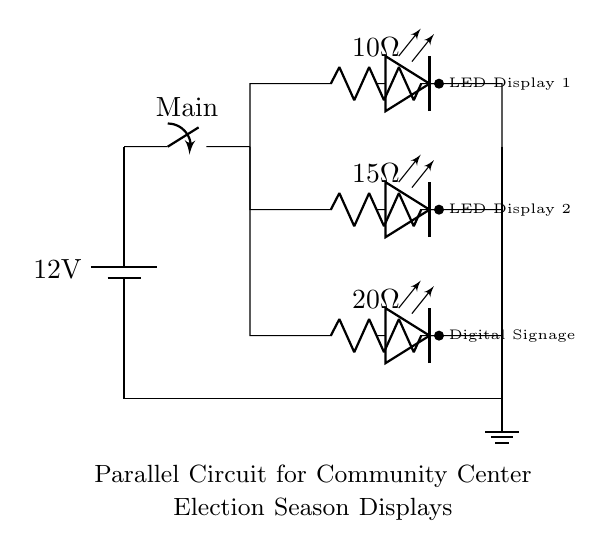What is the voltage of this circuit? The voltage of the circuit is indicated by the battery symbol at the top. It shows that the circuit is powered by a twelve-volt battery.
Answer: twelve volts How many resistors are in this circuit? The circuit contains three resistors, which are drawn as R symbols. They are located in three parallel branches from the main switch.
Answer: three What is the resistance of the LED display branch? The LED display branch is connected to the resistor marked as ten ohms, which is in series with the LED.
Answer: ten ohms What type of circuit is this? This circuit is a parallel circuit since multiple branches are connected across the same two nodes from the power source, allowing each LED and resistor to operate independently.
Answer: parallel If one LED fails, what happens to the others? In a parallel circuit, if one LED fails, the other branches will still function because they are all on separate paths from the power source.
Answer: still function 